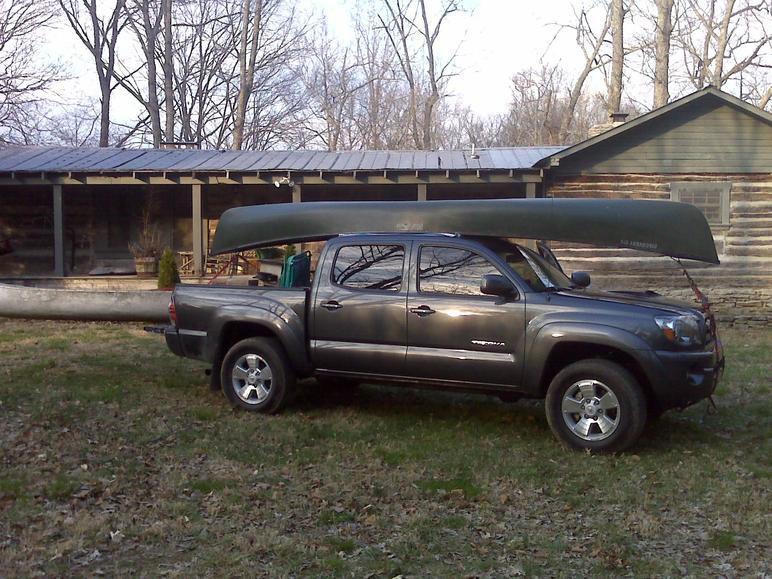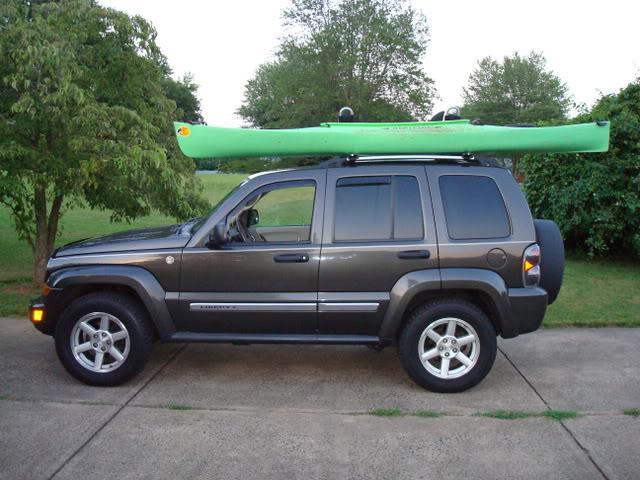The first image is the image on the left, the second image is the image on the right. Evaluate the accuracy of this statement regarding the images: "One of the images contains at least one red kayak.". Is it true? Answer yes or no. No. 